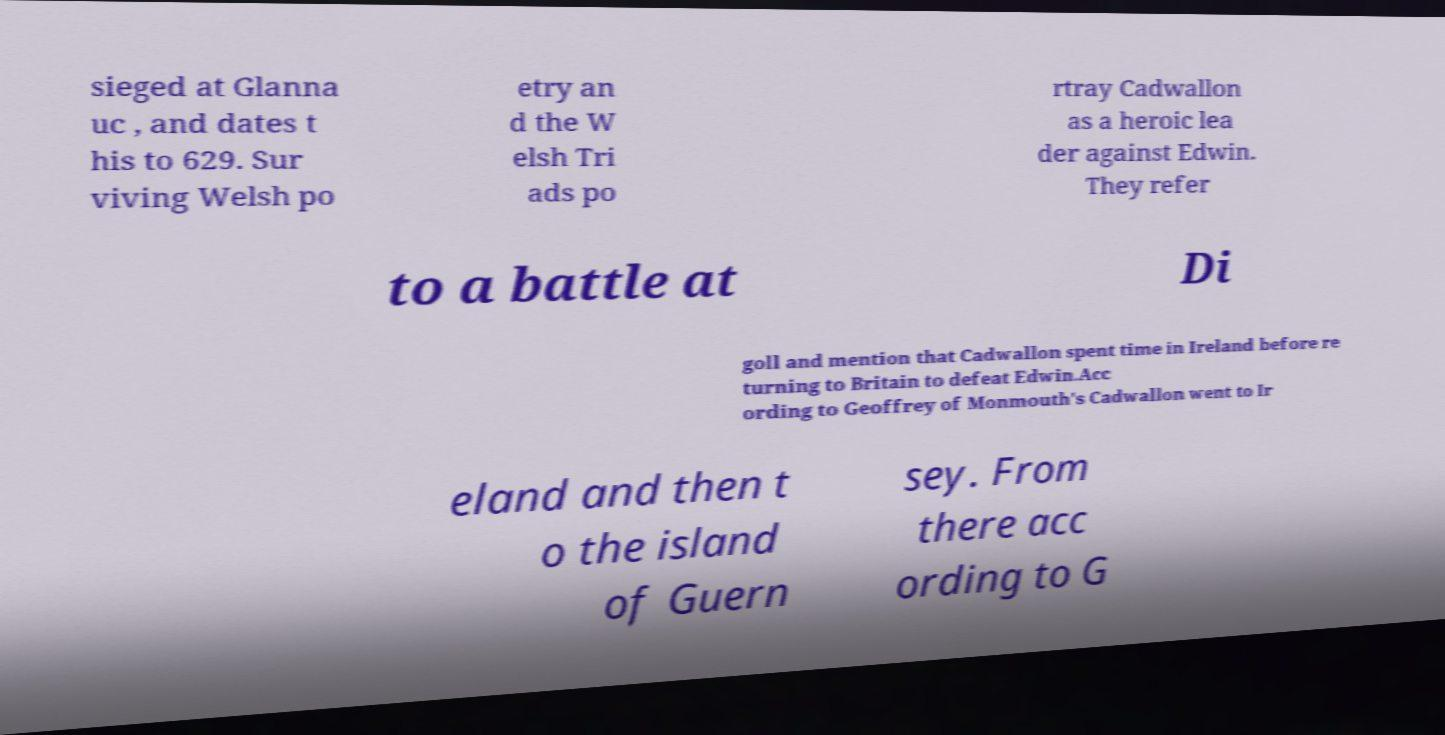Can you read and provide the text displayed in the image?This photo seems to have some interesting text. Can you extract and type it out for me? sieged at Glanna uc , and dates t his to 629. Sur viving Welsh po etry an d the W elsh Tri ads po rtray Cadwallon as a heroic lea der against Edwin. They refer to a battle at Di goll and mention that Cadwallon spent time in Ireland before re turning to Britain to defeat Edwin.Acc ording to Geoffrey of Monmouth's Cadwallon went to Ir eland and then t o the island of Guern sey. From there acc ording to G 